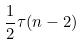Convert formula to latex. <formula><loc_0><loc_0><loc_500><loc_500>\frac { 1 } { 2 } \tau ( n - 2 )</formula> 